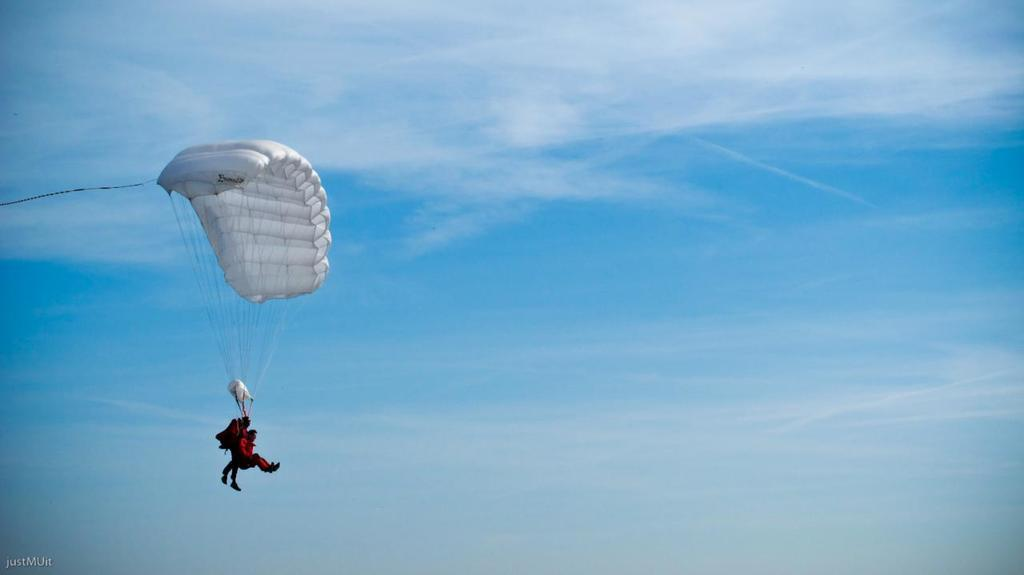How many people are in the image? There are two persons in the image. What are the two persons doing in the image? The two persons are riding on a parachute. What can be seen in the background of the image? The background of the image includes a sky. What is the condition of the sky in the image? The sky appears to be cloudy. What type of flowers can be seen growing near the persons in the image? There are no flowers visible in the image; the two persons are riding on a parachute in a cloudy sky. What subject is being taught in the class depicted in the image? There is no class present in the image; it features two persons riding on a parachute in a cloudy sky. 